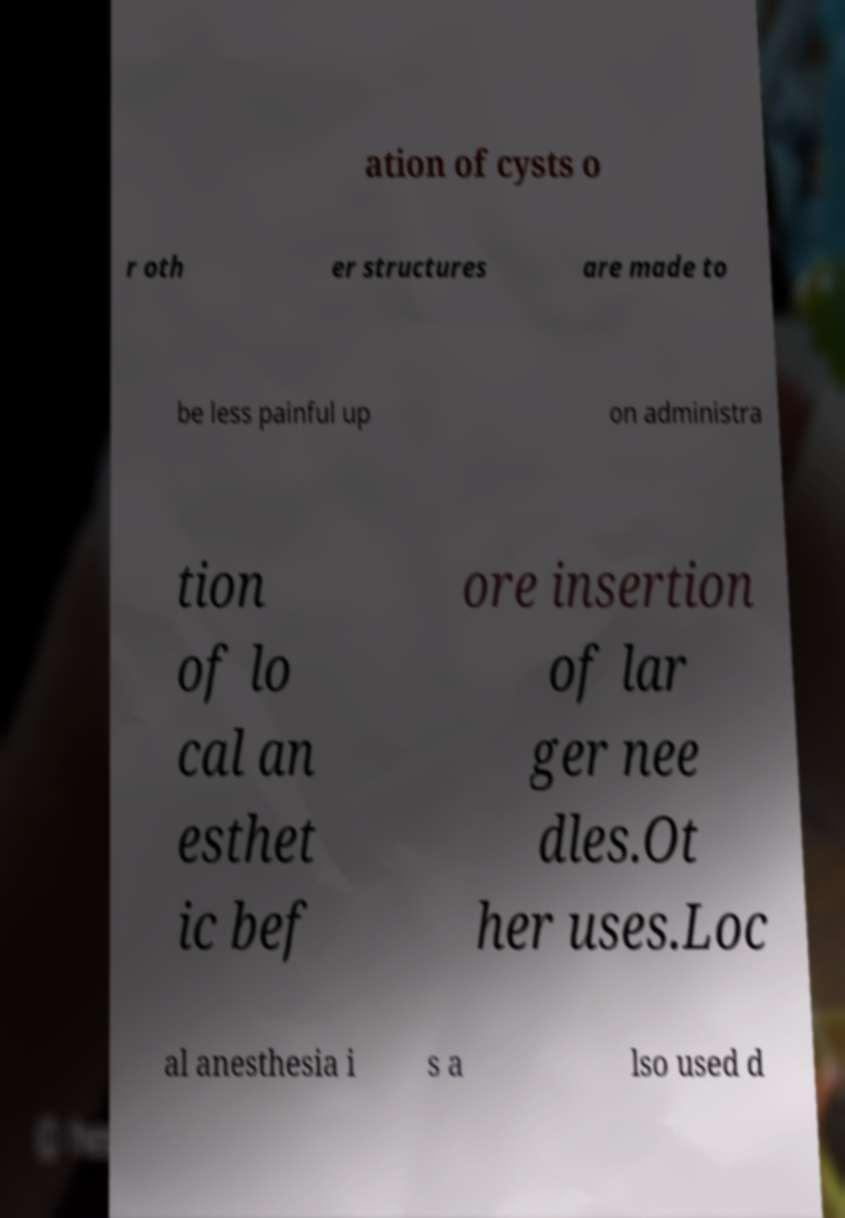Please read and relay the text visible in this image. What does it say? ation of cysts o r oth er structures are made to be less painful up on administra tion of lo cal an esthet ic bef ore insertion of lar ger nee dles.Ot her uses.Loc al anesthesia i s a lso used d 